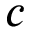<formula> <loc_0><loc_0><loc_500><loc_500>c</formula> 